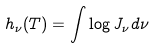<formula> <loc_0><loc_0><loc_500><loc_500>h _ { \nu } ( T ) = \int \log J _ { \nu } d \nu</formula> 